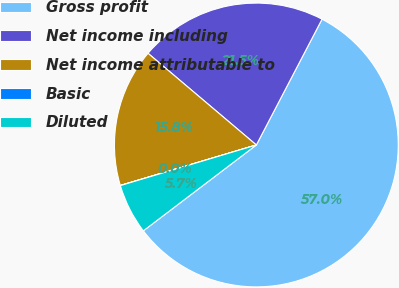<chart> <loc_0><loc_0><loc_500><loc_500><pie_chart><fcel>Gross profit<fcel>Net income including<fcel>Net income attributable to<fcel>Basic<fcel>Diluted<nl><fcel>57.0%<fcel>21.48%<fcel>15.78%<fcel>0.02%<fcel>5.72%<nl></chart> 